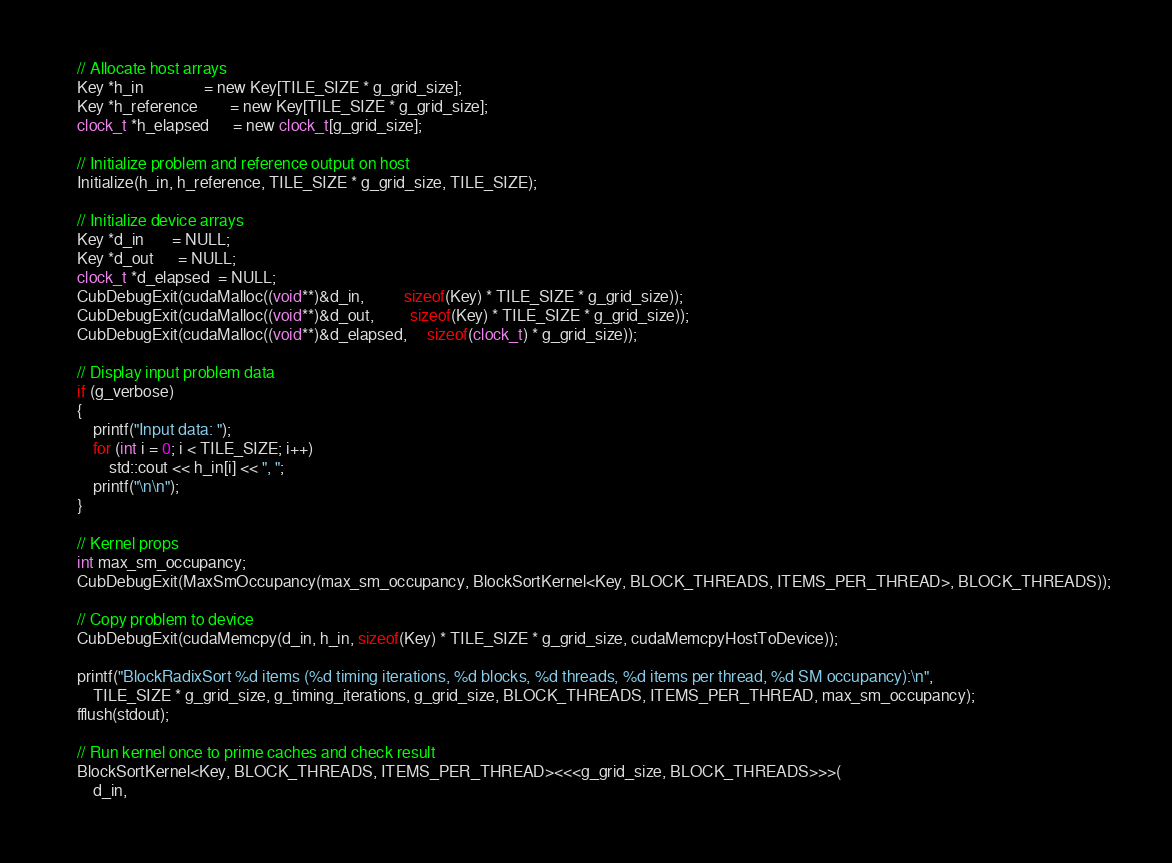<code> <loc_0><loc_0><loc_500><loc_500><_Cuda_>    // Allocate host arrays
    Key *h_in               = new Key[TILE_SIZE * g_grid_size];
    Key *h_reference        = new Key[TILE_SIZE * g_grid_size];
    clock_t *h_elapsed      = new clock_t[g_grid_size];

    // Initialize problem and reference output on host
    Initialize(h_in, h_reference, TILE_SIZE * g_grid_size, TILE_SIZE);

    // Initialize device arrays
    Key *d_in       = NULL;
    Key *d_out      = NULL;
    clock_t *d_elapsed  = NULL;
    CubDebugExit(cudaMalloc((void**)&d_in,          sizeof(Key) * TILE_SIZE * g_grid_size));
    CubDebugExit(cudaMalloc((void**)&d_out,         sizeof(Key) * TILE_SIZE * g_grid_size));
    CubDebugExit(cudaMalloc((void**)&d_elapsed,     sizeof(clock_t) * g_grid_size));

    // Display input problem data
    if (g_verbose)
    {
        printf("Input data: ");
        for (int i = 0; i < TILE_SIZE; i++)
            std::cout << h_in[i] << ", ";
        printf("\n\n");
    }

    // Kernel props
    int max_sm_occupancy;
    CubDebugExit(MaxSmOccupancy(max_sm_occupancy, BlockSortKernel<Key, BLOCK_THREADS, ITEMS_PER_THREAD>, BLOCK_THREADS));

    // Copy problem to device
    CubDebugExit(cudaMemcpy(d_in, h_in, sizeof(Key) * TILE_SIZE * g_grid_size, cudaMemcpyHostToDevice));

    printf("BlockRadixSort %d items (%d timing iterations, %d blocks, %d threads, %d items per thread, %d SM occupancy):\n",
        TILE_SIZE * g_grid_size, g_timing_iterations, g_grid_size, BLOCK_THREADS, ITEMS_PER_THREAD, max_sm_occupancy);
    fflush(stdout);

    // Run kernel once to prime caches and check result
    BlockSortKernel<Key, BLOCK_THREADS, ITEMS_PER_THREAD><<<g_grid_size, BLOCK_THREADS>>>(
        d_in,</code> 